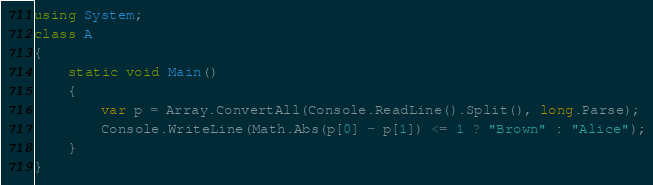Convert code to text. <code><loc_0><loc_0><loc_500><loc_500><_C#_>using System;
class A
{
    static void Main()
    {
        var p = Array.ConvertAll(Console.ReadLine().Split(), long.Parse);
        Console.WriteLine(Math.Abs(p[0] - p[1]) <= 1 ? "Brown" : "Alice");
    }
}
</code> 